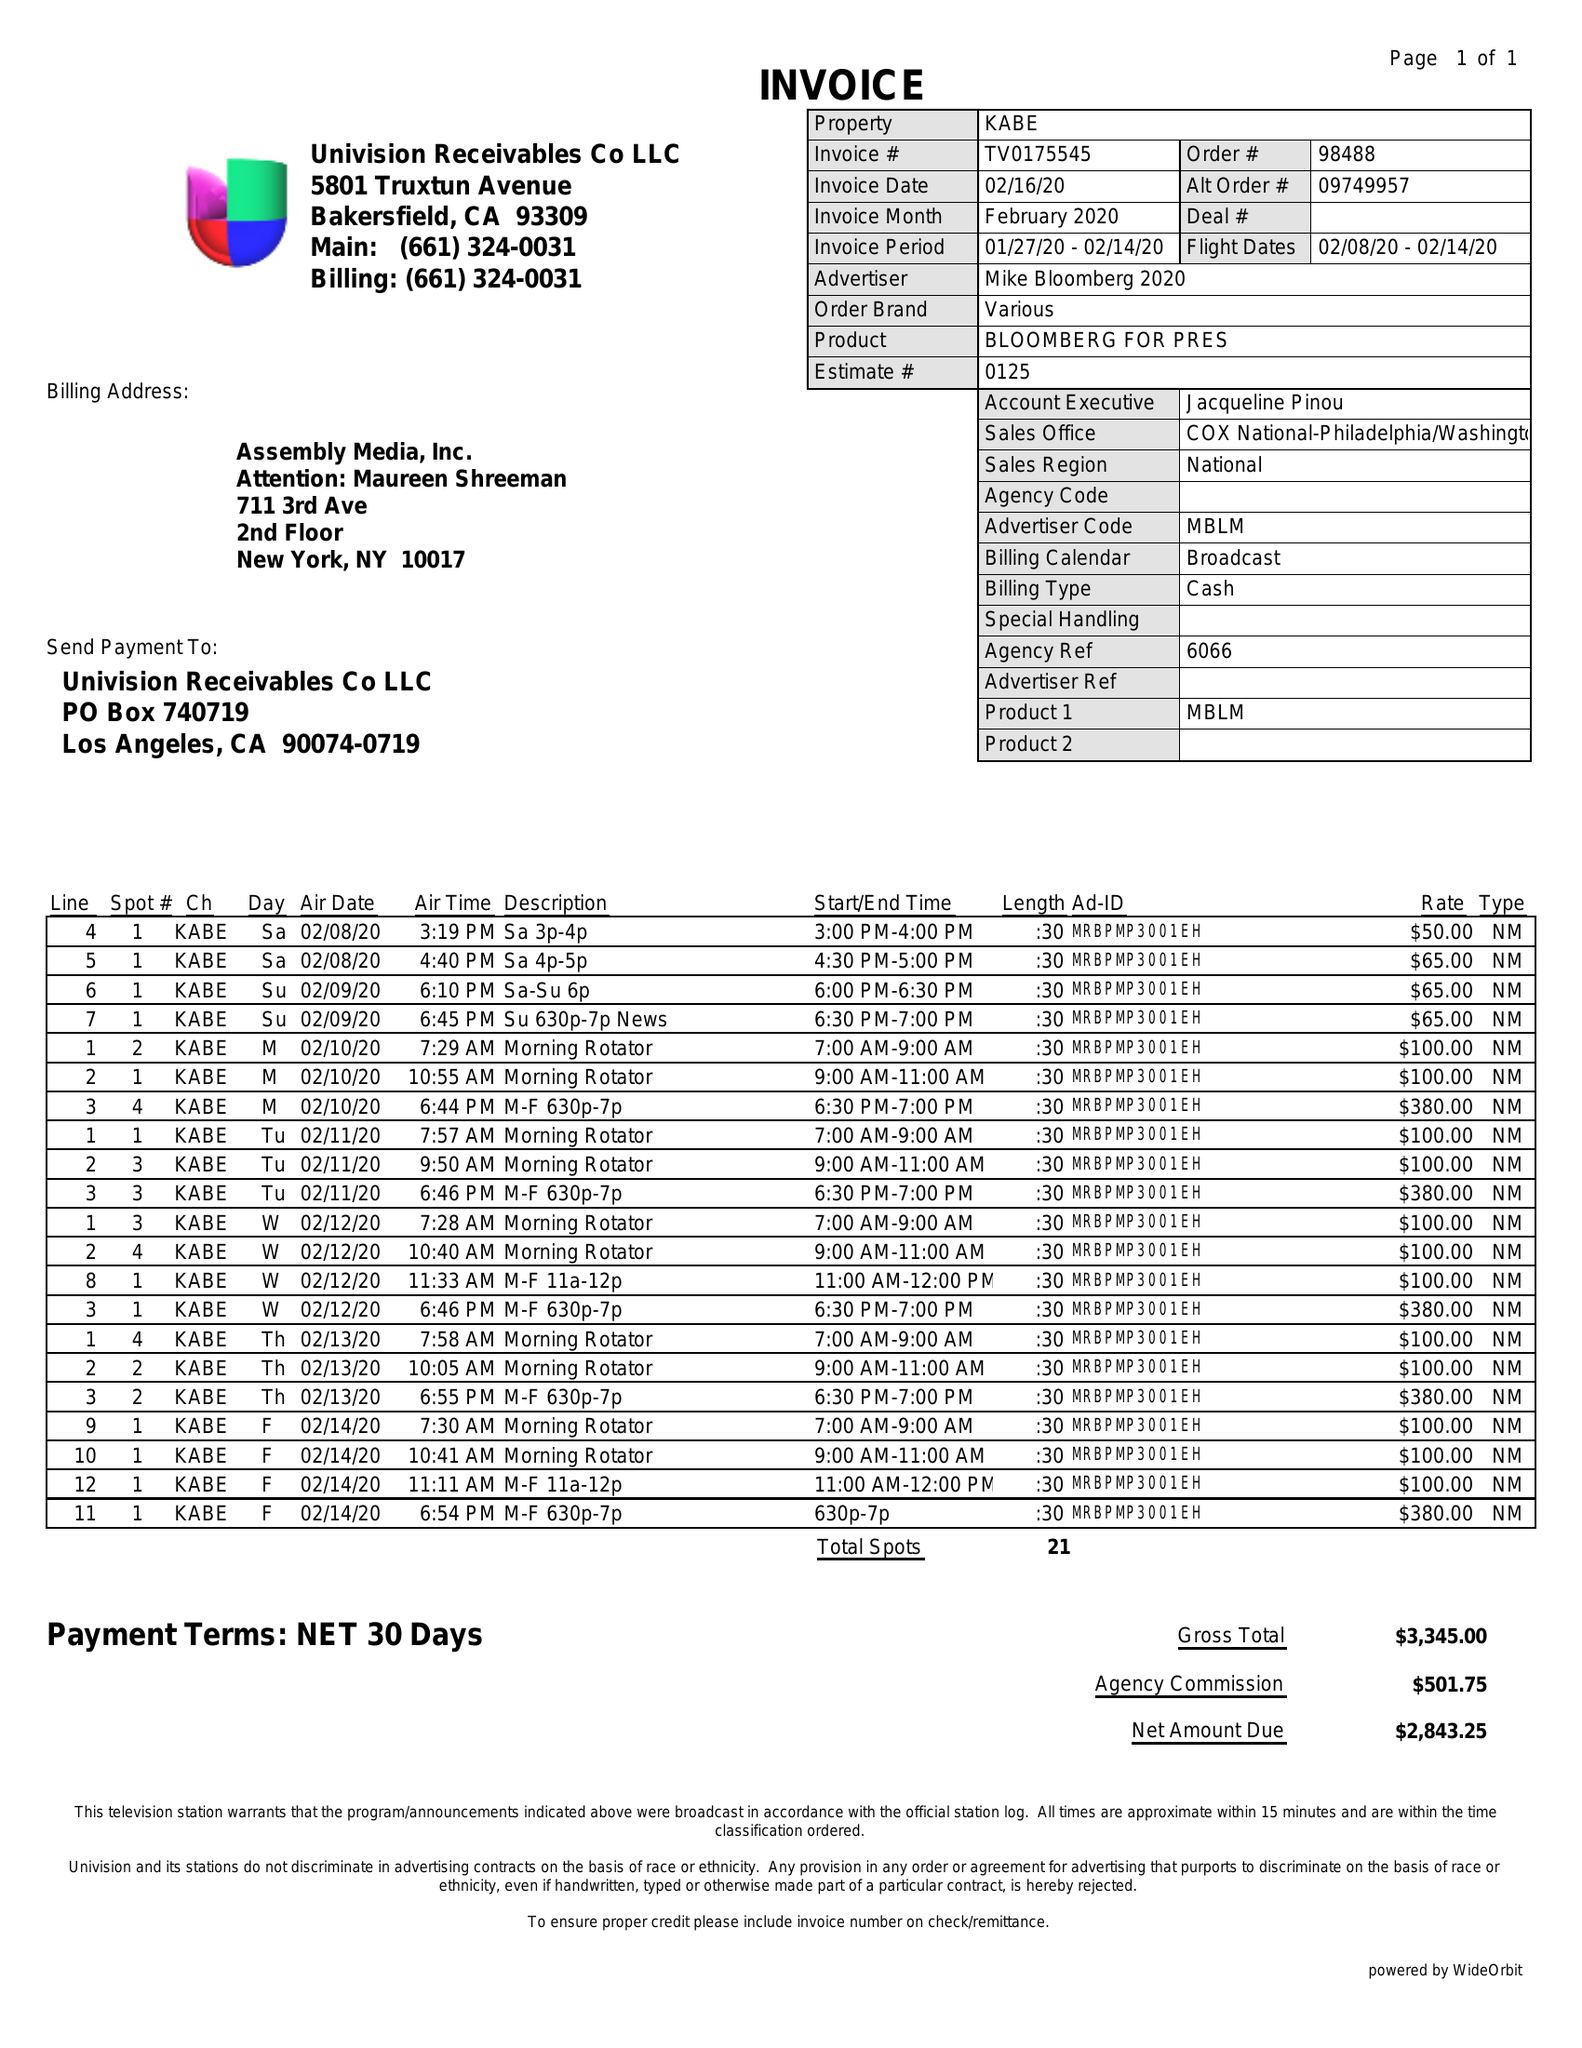What is the value for the advertiser?
Answer the question using a single word or phrase. MIKE BLOOMBERG 2020 